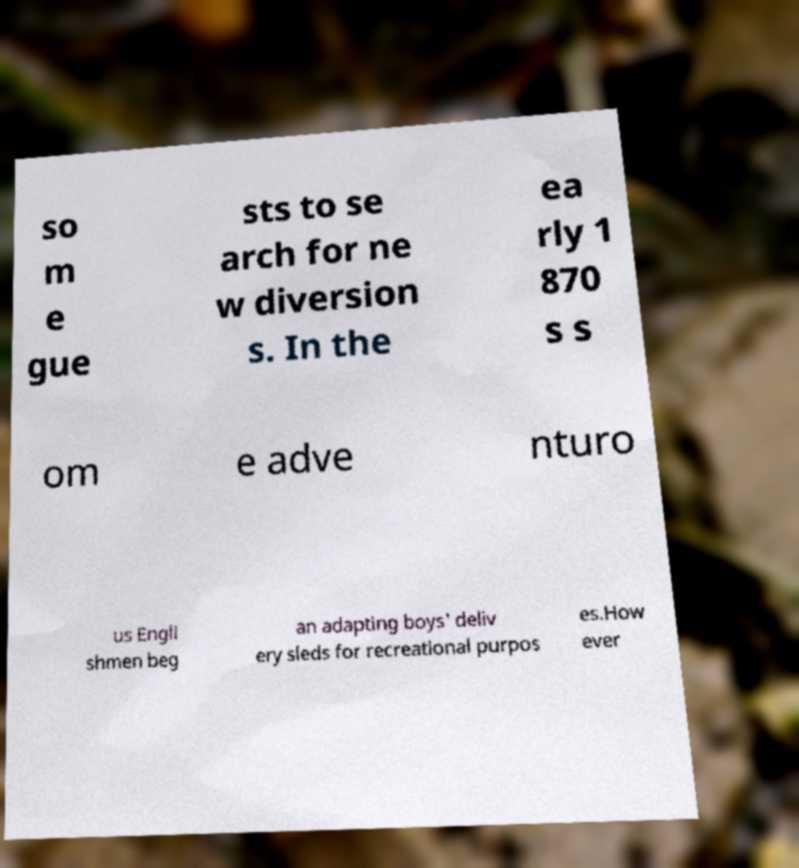What messages or text are displayed in this image? I need them in a readable, typed format. so m e gue sts to se arch for ne w diversion s. In the ea rly 1 870 s s om e adve nturo us Engli shmen beg an adapting boys' deliv ery sleds for recreational purpos es.How ever 